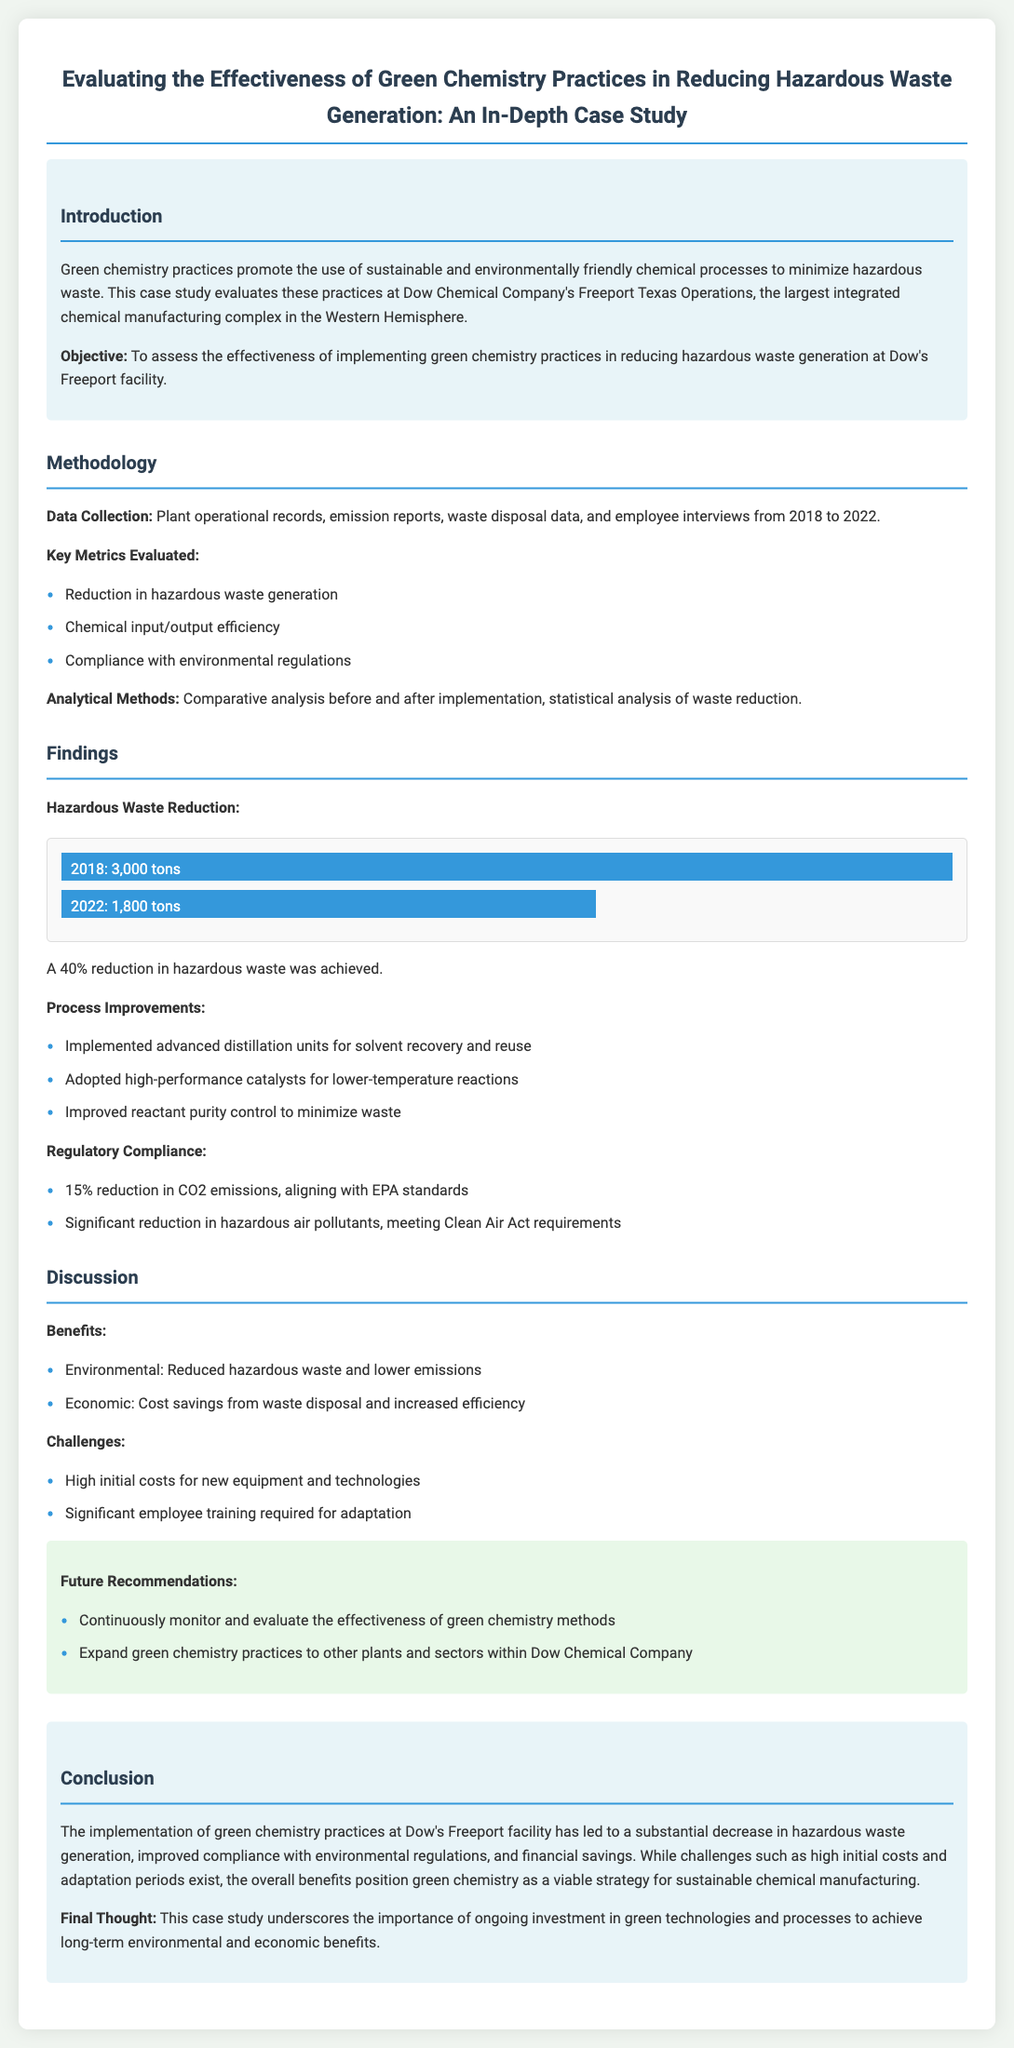What is the location of Dow Chemical's operations evaluated in the study? The document specifies that the case study evaluates Dow Chemical Company's Freeport Texas Operations.
Answer: Freeport Texas What percentage reduction in hazardous waste was achieved by 2022? The findings section presents that there was a 40% reduction in hazardous waste generation by 2022.
Answer: 40% What were the key metrics evaluated in the study? The methodology section lists three key metrics evaluated, including reduction in hazardous waste generation, chemical input/output efficiency, and compliance with environmental regulations.
Answer: Reduction in hazardous waste generation, chemical input/output efficiency, compliance with environmental regulations How much did CO2 emissions reduce? The regulatory compliance findings mention a 15% reduction in CO2 emissions, aligning with EPA standards.
Answer: 15% What is one benefit of implementing green chemistry practices mentioned in the discussion? The benefits section outlines two environmental and economic aspects, highlighting that reduced hazardous waste and lower emissions are significant benefits.
Answer: Reduced hazardous waste What is one challenge faced during the implementation of green chemistry practices? The discussion mentions challenges, including high initial costs for new equipment and technologies as a significant barrier.
Answer: High initial costs What year range was covered for data collection in the study? The methodology section indicates the data collection period spans from 2018 to 2022.
Answer: 2018 to 2022 What is one recommendation for future practices mentioned in the document? The recommendations section suggests continuously monitoring and evaluating the effectiveness of green chemistry methods as one of the future recommendations.
Answer: Continuously monitor and evaluate the effectiveness of green chemistry methods 